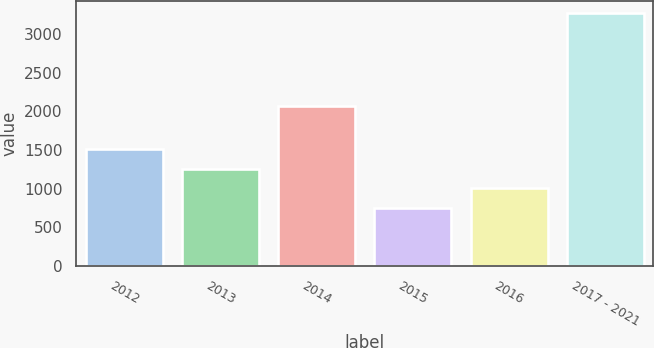Convert chart to OTSL. <chart><loc_0><loc_0><loc_500><loc_500><bar_chart><fcel>2012<fcel>2013<fcel>2014<fcel>2015<fcel>2016<fcel>2017 - 2021<nl><fcel>1510<fcel>1259<fcel>2063<fcel>757<fcel>1008<fcel>3267<nl></chart> 